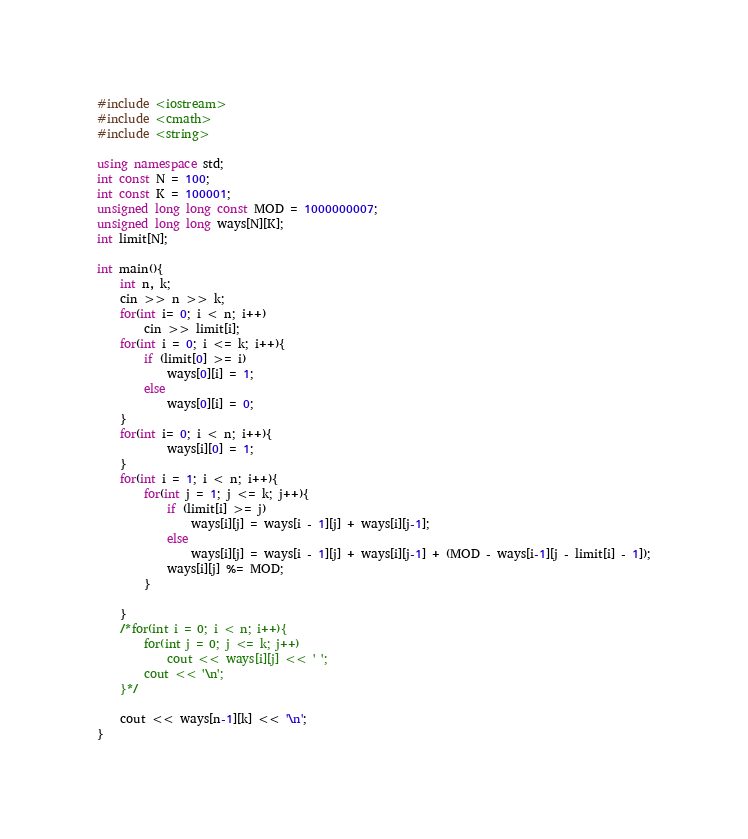<code> <loc_0><loc_0><loc_500><loc_500><_C++_>#include <iostream>
#include <cmath>
#include <string>

using namespace std;
int const N = 100;
int const K = 100001;
unsigned long long const MOD = 1000000007;
unsigned long long ways[N][K];
int limit[N];

int main(){
    int n, k;
    cin >> n >> k;
    for(int i= 0; i < n; i++)
        cin >> limit[i];
    for(int i = 0; i <= k; i++){
        if (limit[0] >= i)
            ways[0][i] = 1;
        else
            ways[0][i] = 0;
    }
    for(int i= 0; i < n; i++){
            ways[i][0] = 1;
    }
    for(int i = 1; i < n; i++){
        for(int j = 1; j <= k; j++){
            if (limit[i] >= j)
                ways[i][j] = ways[i - 1][j] + ways[i][j-1];
            else 
                ways[i][j] = ways[i - 1][j] + ways[i][j-1] + (MOD - ways[i-1][j - limit[i] - 1]);
            ways[i][j] %= MOD;
        }

    }
    /*for(int i = 0; i < n; i++){
        for(int j = 0; j <= k; j++)
            cout << ways[i][j] << ' ';
        cout << '\n';
    }*/
    
    cout << ways[n-1][k] << '\n';
}</code> 